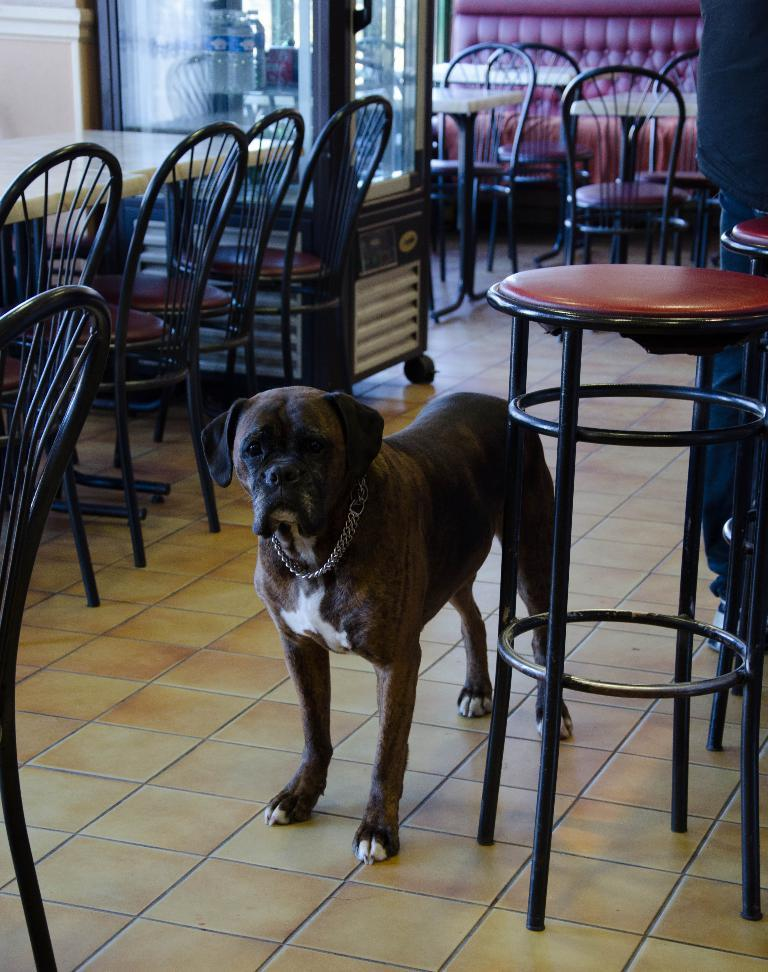What type of animal can be seen in the picture? There is a dog in the picture. What type of furniture is present in the picture? There are chairs and tables in the picture. What type of appliance is visible in the picture? There is a fridge in the picture. What is stored inside the fridge? There are bottles inside the fridge. What type of rock can be seen in the picture? There is no rock present in the picture. What activity is the dog engaged in within the picture? The provided facts do not mention any specific activity the dog is engaged in. 